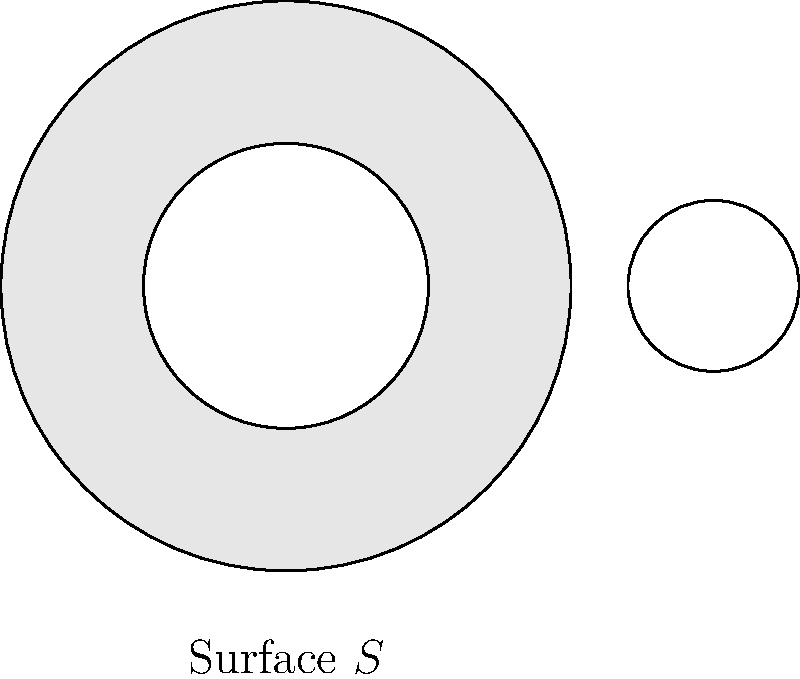In topology, the genus of a surface is a fundamental characteristic. Consider the geometric surface $S$ shown above. Based on the number of holes visible, what is the genus of this surface? To determine the genus of the surface, we need to follow these steps:

1. Understand the definition of genus:
   The genus of a surface is the number of handles or holes it has.

2. Count the number of holes in the given surface:
   - There is one large hole in the center of the surface.
   - There is another smaller hole on the right side of the surface.

3. Calculate the genus:
   - Each hole contributes 1 to the genus.
   - Total number of holes = 1 (center) + 1 (right side) = 2

4. Conclude:
   The genus of the surface is equal to the number of holes, which is 2.

In topological terms, this surface is homeomorphic to a double torus, also known as a 2-torus or genus-2 surface.
Answer: 2 